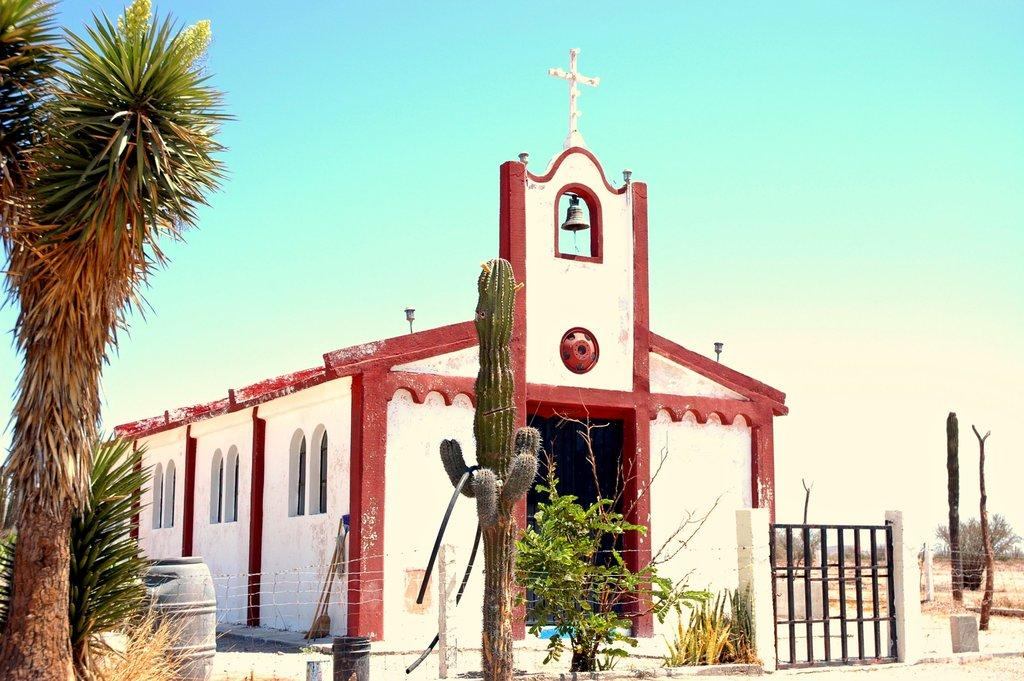What type of vegetation can be seen in the image? There is a tree and a cactus plant in the image. Are there any plants in containers in the image? Yes, there are plants kept in pots in the image. What type of sheet is covering the territory in the image? There is no sheet or territory present in the image; it features a tree, a cactus plant, and plants in pots. 